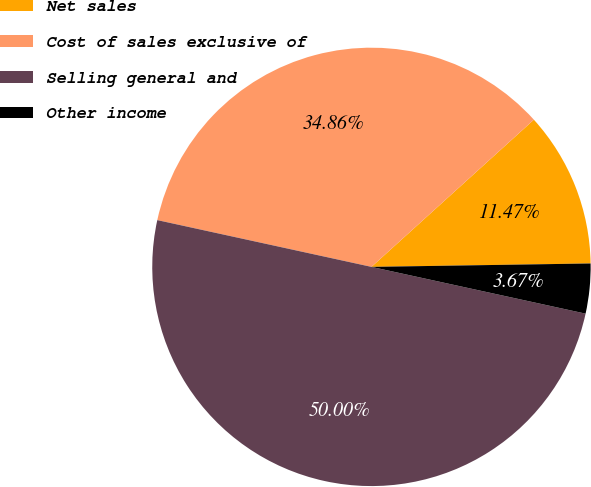<chart> <loc_0><loc_0><loc_500><loc_500><pie_chart><fcel>Net sales<fcel>Cost of sales exclusive of<fcel>Selling general and<fcel>Other income<nl><fcel>11.47%<fcel>34.86%<fcel>50.0%<fcel>3.67%<nl></chart> 